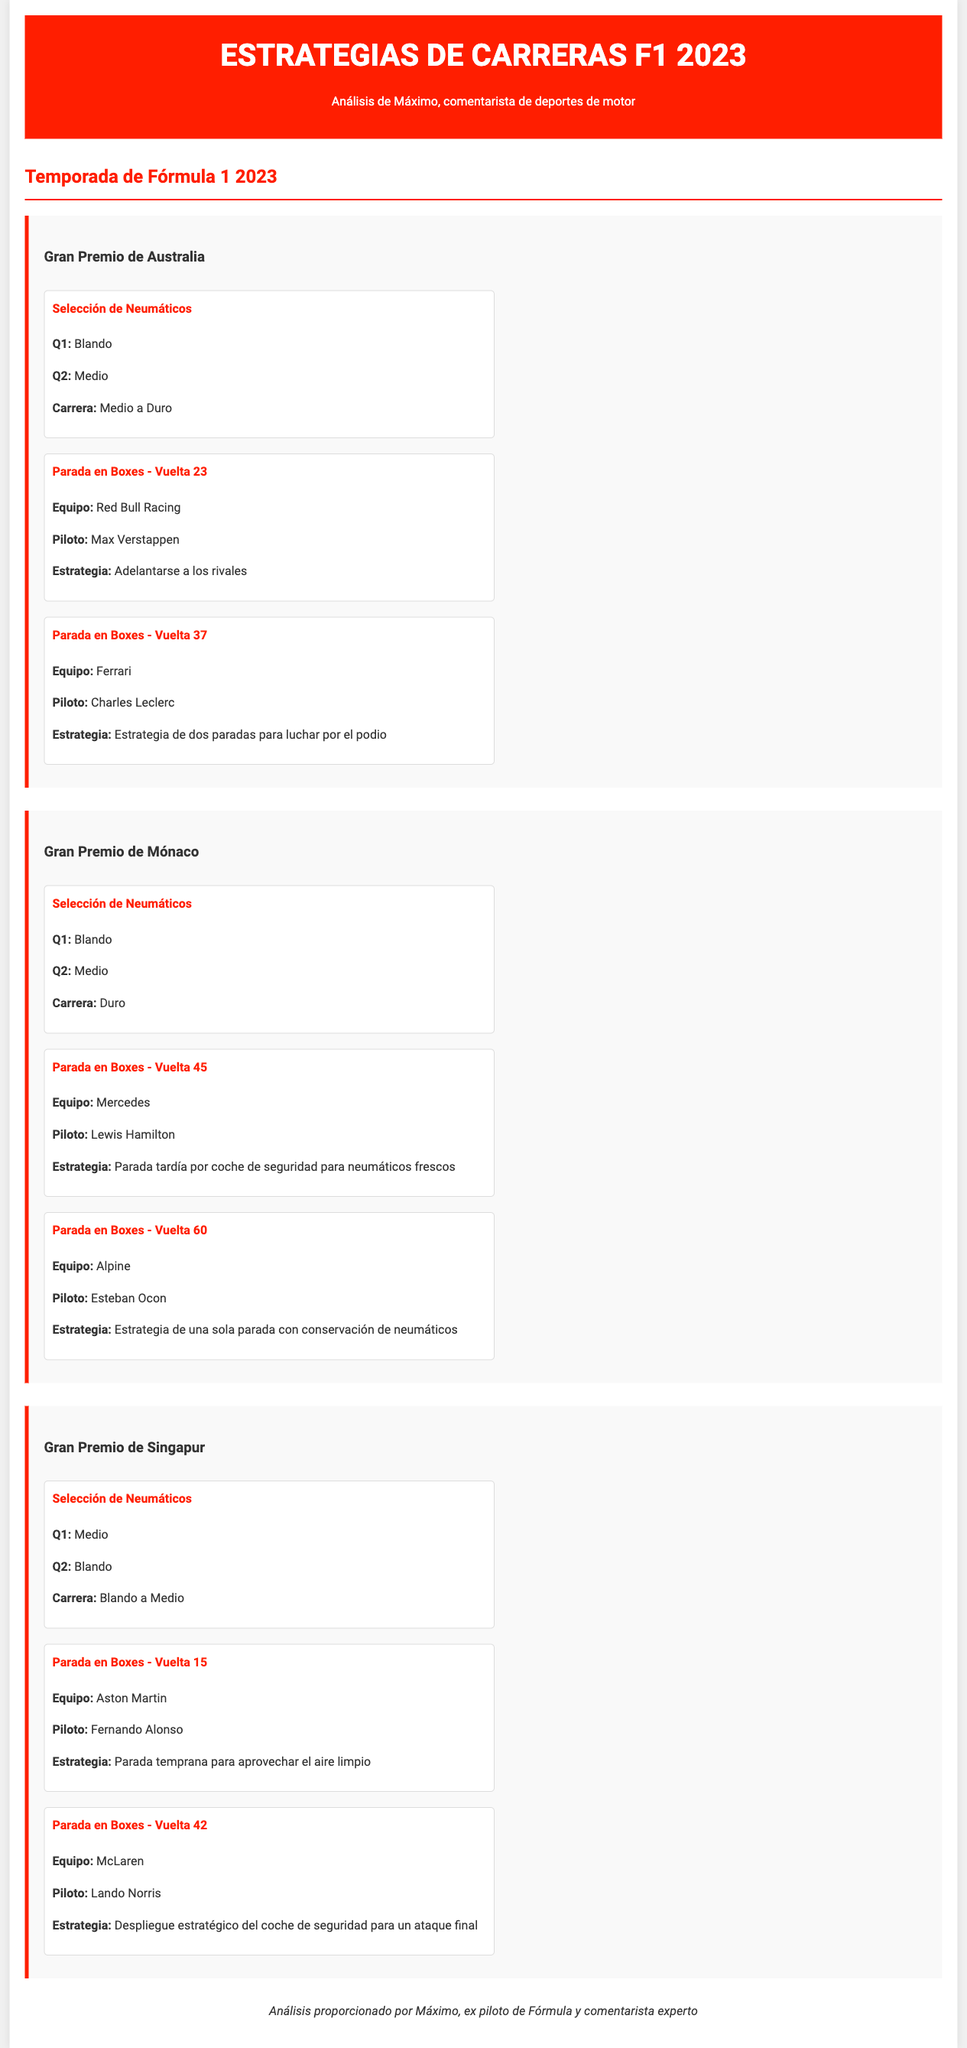¿Qué neumáticos usó Max Verstappen en la clasificación? En la Clasificación Q1, Max Verstappen usó neumáticos Blandos.
Answer: Blando ¿Cuál fue la estrategia de parada en boxes de Charles Leclerc en el Gran Premio de Australia? Charles Leclerc realizó una parada en boxes en la vuelta 37, con una estrategia de dos paradas para luchar por el podio.
Answer: Estrategia de dos paradas ¿Cómo se llamaba el piloto que hizo una parada tardía en el Gran Premio de Mónaco? Lewis Hamilton de Mercedes hizo una parada tardía en la vuelta 45.
Answer: Lewis Hamilton ¿Cuántas paradas realizó Fernando Alonso en el Gran Premio de Singapur? Fernando Alonso realizó una parada en boxes en la vuelta 15.
Answer: Una parada ¿Qué neumáticos usaron los pilotos en la carrera del Gran Premio de Singapur? En la carrera, los pilotos usaron neumáticos Blando a Medio.
Answer: Blando a Medio 